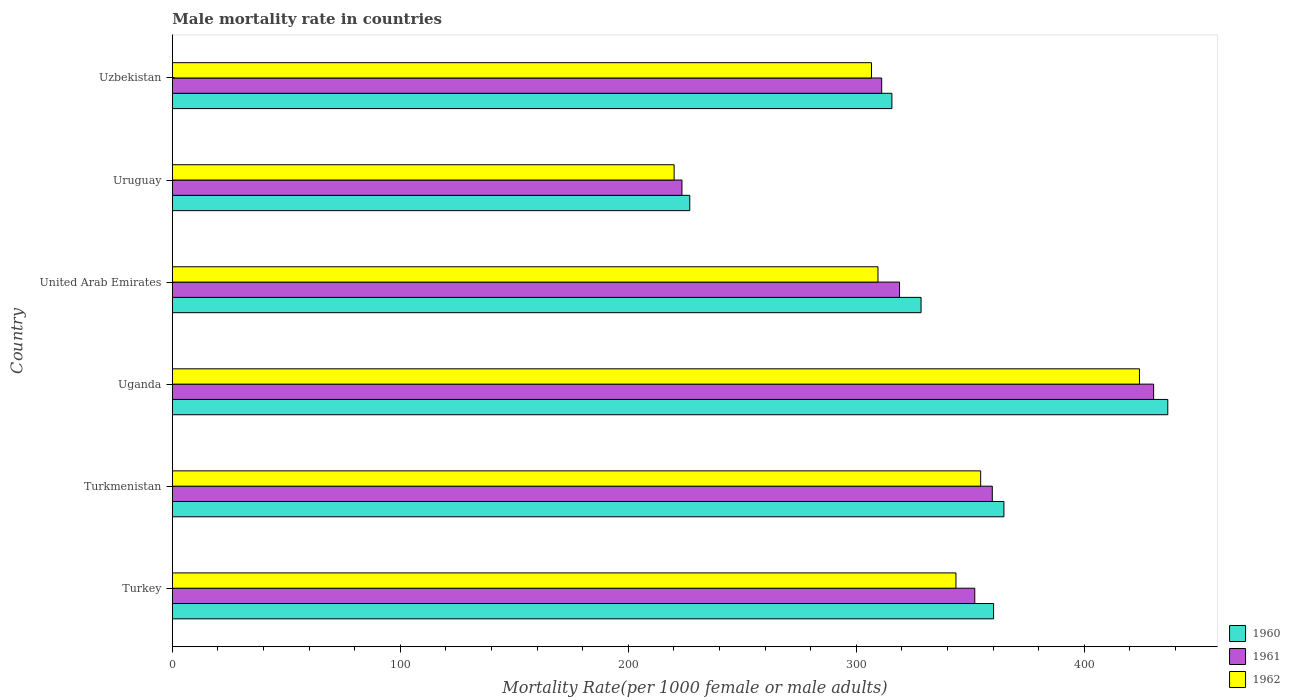How many groups of bars are there?
Your answer should be very brief. 6. How many bars are there on the 2nd tick from the bottom?
Your response must be concise. 3. What is the label of the 1st group of bars from the top?
Offer a very short reply. Uzbekistan. What is the male mortality rate in 1962 in Uganda?
Your answer should be compact. 424.16. Across all countries, what is the maximum male mortality rate in 1961?
Keep it short and to the point. 430.37. Across all countries, what is the minimum male mortality rate in 1962?
Provide a succinct answer. 220.07. In which country was the male mortality rate in 1962 maximum?
Provide a short and direct response. Uganda. In which country was the male mortality rate in 1962 minimum?
Give a very brief answer. Uruguay. What is the total male mortality rate in 1961 in the graph?
Offer a very short reply. 1995.46. What is the difference between the male mortality rate in 1962 in Turkey and that in Uganda?
Your answer should be very brief. -80.48. What is the difference between the male mortality rate in 1960 in Turkmenistan and the male mortality rate in 1962 in United Arab Emirates?
Ensure brevity in your answer.  55.24. What is the average male mortality rate in 1961 per country?
Ensure brevity in your answer.  332.58. What is the difference between the male mortality rate in 1961 and male mortality rate in 1960 in Uganda?
Your response must be concise. -6.21. What is the ratio of the male mortality rate in 1962 in Uganda to that in Uruguay?
Provide a short and direct response. 1.93. Is the male mortality rate in 1962 in Turkey less than that in Uruguay?
Your response must be concise. No. Is the difference between the male mortality rate in 1961 in Uruguay and Uzbekistan greater than the difference between the male mortality rate in 1960 in Uruguay and Uzbekistan?
Provide a succinct answer. Yes. What is the difference between the highest and the second highest male mortality rate in 1961?
Make the answer very short. 70.76. What is the difference between the highest and the lowest male mortality rate in 1960?
Ensure brevity in your answer.  209.65. In how many countries, is the male mortality rate in 1960 greater than the average male mortality rate in 1960 taken over all countries?
Your answer should be very brief. 3. Is the sum of the male mortality rate in 1962 in Turkey and United Arab Emirates greater than the maximum male mortality rate in 1961 across all countries?
Give a very brief answer. Yes. What does the 1st bar from the top in Uzbekistan represents?
Ensure brevity in your answer.  1962. Is it the case that in every country, the sum of the male mortality rate in 1962 and male mortality rate in 1960 is greater than the male mortality rate in 1961?
Ensure brevity in your answer.  Yes. How many bars are there?
Give a very brief answer. 18. Are all the bars in the graph horizontal?
Your answer should be compact. Yes. How many countries are there in the graph?
Offer a terse response. 6. What is the difference between two consecutive major ticks on the X-axis?
Make the answer very short. 100. Are the values on the major ticks of X-axis written in scientific E-notation?
Provide a succinct answer. No. Does the graph contain any zero values?
Offer a very short reply. No. Does the graph contain grids?
Offer a terse response. No. How are the legend labels stacked?
Provide a short and direct response. Vertical. What is the title of the graph?
Make the answer very short. Male mortality rate in countries. Does "2009" appear as one of the legend labels in the graph?
Offer a very short reply. No. What is the label or title of the X-axis?
Make the answer very short. Mortality Rate(per 1000 female or male adults). What is the label or title of the Y-axis?
Keep it short and to the point. Country. What is the Mortality Rate(per 1000 female or male adults) in 1960 in Turkey?
Offer a terse response. 360.19. What is the Mortality Rate(per 1000 female or male adults) in 1961 in Turkey?
Offer a very short reply. 351.93. What is the Mortality Rate(per 1000 female or male adults) in 1962 in Turkey?
Your answer should be very brief. 343.68. What is the Mortality Rate(per 1000 female or male adults) in 1960 in Turkmenistan?
Provide a short and direct response. 364.72. What is the Mortality Rate(per 1000 female or male adults) in 1961 in Turkmenistan?
Provide a short and direct response. 359.62. What is the Mortality Rate(per 1000 female or male adults) of 1962 in Turkmenistan?
Provide a short and direct response. 354.52. What is the Mortality Rate(per 1000 female or male adults) of 1960 in Uganda?
Keep it short and to the point. 436.58. What is the Mortality Rate(per 1000 female or male adults) in 1961 in Uganda?
Offer a terse response. 430.37. What is the Mortality Rate(per 1000 female or male adults) of 1962 in Uganda?
Provide a succinct answer. 424.16. What is the Mortality Rate(per 1000 female or male adults) of 1960 in United Arab Emirates?
Offer a terse response. 328.38. What is the Mortality Rate(per 1000 female or male adults) of 1961 in United Arab Emirates?
Give a very brief answer. 318.93. What is the Mortality Rate(per 1000 female or male adults) of 1962 in United Arab Emirates?
Your answer should be compact. 309.48. What is the Mortality Rate(per 1000 female or male adults) of 1960 in Uruguay?
Provide a succinct answer. 226.93. What is the Mortality Rate(per 1000 female or male adults) of 1961 in Uruguay?
Offer a terse response. 223.5. What is the Mortality Rate(per 1000 female or male adults) in 1962 in Uruguay?
Provide a short and direct response. 220.07. What is the Mortality Rate(per 1000 female or male adults) in 1960 in Uzbekistan?
Offer a very short reply. 315.58. What is the Mortality Rate(per 1000 female or male adults) of 1961 in Uzbekistan?
Your answer should be compact. 311.11. What is the Mortality Rate(per 1000 female or male adults) in 1962 in Uzbekistan?
Provide a succinct answer. 306.63. Across all countries, what is the maximum Mortality Rate(per 1000 female or male adults) in 1960?
Offer a terse response. 436.58. Across all countries, what is the maximum Mortality Rate(per 1000 female or male adults) of 1961?
Keep it short and to the point. 430.37. Across all countries, what is the maximum Mortality Rate(per 1000 female or male adults) in 1962?
Your answer should be compact. 424.16. Across all countries, what is the minimum Mortality Rate(per 1000 female or male adults) of 1960?
Provide a succinct answer. 226.93. Across all countries, what is the minimum Mortality Rate(per 1000 female or male adults) of 1961?
Offer a terse response. 223.5. Across all countries, what is the minimum Mortality Rate(per 1000 female or male adults) of 1962?
Your answer should be compact. 220.07. What is the total Mortality Rate(per 1000 female or male adults) of 1960 in the graph?
Ensure brevity in your answer.  2032.38. What is the total Mortality Rate(per 1000 female or male adults) of 1961 in the graph?
Provide a succinct answer. 1995.46. What is the total Mortality Rate(per 1000 female or male adults) of 1962 in the graph?
Provide a succinct answer. 1958.54. What is the difference between the Mortality Rate(per 1000 female or male adults) in 1960 in Turkey and that in Turkmenistan?
Your response must be concise. -4.53. What is the difference between the Mortality Rate(per 1000 female or male adults) of 1961 in Turkey and that in Turkmenistan?
Keep it short and to the point. -7.69. What is the difference between the Mortality Rate(per 1000 female or male adults) in 1962 in Turkey and that in Turkmenistan?
Your answer should be compact. -10.84. What is the difference between the Mortality Rate(per 1000 female or male adults) of 1960 in Turkey and that in Uganda?
Give a very brief answer. -76.4. What is the difference between the Mortality Rate(per 1000 female or male adults) of 1961 in Turkey and that in Uganda?
Offer a terse response. -78.44. What is the difference between the Mortality Rate(per 1000 female or male adults) in 1962 in Turkey and that in Uganda?
Ensure brevity in your answer.  -80.48. What is the difference between the Mortality Rate(per 1000 female or male adults) in 1960 in Turkey and that in United Arab Emirates?
Make the answer very short. 31.81. What is the difference between the Mortality Rate(per 1000 female or male adults) in 1961 in Turkey and that in United Arab Emirates?
Offer a very short reply. 33. What is the difference between the Mortality Rate(per 1000 female or male adults) of 1962 in Turkey and that in United Arab Emirates?
Your response must be concise. 34.2. What is the difference between the Mortality Rate(per 1000 female or male adults) in 1960 in Turkey and that in Uruguay?
Your answer should be compact. 133.25. What is the difference between the Mortality Rate(per 1000 female or male adults) in 1961 in Turkey and that in Uruguay?
Your answer should be very brief. 128.43. What is the difference between the Mortality Rate(per 1000 female or male adults) of 1962 in Turkey and that in Uruguay?
Provide a short and direct response. 123.61. What is the difference between the Mortality Rate(per 1000 female or male adults) of 1960 in Turkey and that in Uzbekistan?
Your response must be concise. 44.6. What is the difference between the Mortality Rate(per 1000 female or male adults) in 1961 in Turkey and that in Uzbekistan?
Give a very brief answer. 40.83. What is the difference between the Mortality Rate(per 1000 female or male adults) of 1962 in Turkey and that in Uzbekistan?
Ensure brevity in your answer.  37.05. What is the difference between the Mortality Rate(per 1000 female or male adults) of 1960 in Turkmenistan and that in Uganda?
Provide a short and direct response. -71.87. What is the difference between the Mortality Rate(per 1000 female or male adults) in 1961 in Turkmenistan and that in Uganda?
Provide a succinct answer. -70.76. What is the difference between the Mortality Rate(per 1000 female or male adults) in 1962 in Turkmenistan and that in Uganda?
Ensure brevity in your answer.  -69.64. What is the difference between the Mortality Rate(per 1000 female or male adults) of 1960 in Turkmenistan and that in United Arab Emirates?
Offer a terse response. 36.34. What is the difference between the Mortality Rate(per 1000 female or male adults) of 1961 in Turkmenistan and that in United Arab Emirates?
Provide a succinct answer. 40.69. What is the difference between the Mortality Rate(per 1000 female or male adults) of 1962 in Turkmenistan and that in United Arab Emirates?
Offer a very short reply. 45.04. What is the difference between the Mortality Rate(per 1000 female or male adults) in 1960 in Turkmenistan and that in Uruguay?
Keep it short and to the point. 137.78. What is the difference between the Mortality Rate(per 1000 female or male adults) of 1961 in Turkmenistan and that in Uruguay?
Provide a succinct answer. 136.12. What is the difference between the Mortality Rate(per 1000 female or male adults) of 1962 in Turkmenistan and that in Uruguay?
Provide a short and direct response. 134.45. What is the difference between the Mortality Rate(per 1000 female or male adults) of 1960 in Turkmenistan and that in Uzbekistan?
Make the answer very short. 49.14. What is the difference between the Mortality Rate(per 1000 female or male adults) of 1961 in Turkmenistan and that in Uzbekistan?
Offer a terse response. 48.51. What is the difference between the Mortality Rate(per 1000 female or male adults) of 1962 in Turkmenistan and that in Uzbekistan?
Your answer should be very brief. 47.89. What is the difference between the Mortality Rate(per 1000 female or male adults) of 1960 in Uganda and that in United Arab Emirates?
Your response must be concise. 108.21. What is the difference between the Mortality Rate(per 1000 female or male adults) in 1961 in Uganda and that in United Arab Emirates?
Ensure brevity in your answer.  111.44. What is the difference between the Mortality Rate(per 1000 female or male adults) in 1962 in Uganda and that in United Arab Emirates?
Your answer should be very brief. 114.68. What is the difference between the Mortality Rate(per 1000 female or male adults) in 1960 in Uganda and that in Uruguay?
Ensure brevity in your answer.  209.65. What is the difference between the Mortality Rate(per 1000 female or male adults) of 1961 in Uganda and that in Uruguay?
Keep it short and to the point. 206.87. What is the difference between the Mortality Rate(per 1000 female or male adults) of 1962 in Uganda and that in Uruguay?
Offer a terse response. 204.09. What is the difference between the Mortality Rate(per 1000 female or male adults) of 1960 in Uganda and that in Uzbekistan?
Offer a very short reply. 121. What is the difference between the Mortality Rate(per 1000 female or male adults) in 1961 in Uganda and that in Uzbekistan?
Your response must be concise. 119.27. What is the difference between the Mortality Rate(per 1000 female or male adults) of 1962 in Uganda and that in Uzbekistan?
Provide a succinct answer. 117.53. What is the difference between the Mortality Rate(per 1000 female or male adults) of 1960 in United Arab Emirates and that in Uruguay?
Give a very brief answer. 101.44. What is the difference between the Mortality Rate(per 1000 female or male adults) in 1961 in United Arab Emirates and that in Uruguay?
Offer a terse response. 95.43. What is the difference between the Mortality Rate(per 1000 female or male adults) of 1962 in United Arab Emirates and that in Uruguay?
Your answer should be compact. 89.41. What is the difference between the Mortality Rate(per 1000 female or male adults) of 1960 in United Arab Emirates and that in Uzbekistan?
Your answer should be very brief. 12.8. What is the difference between the Mortality Rate(per 1000 female or male adults) in 1961 in United Arab Emirates and that in Uzbekistan?
Ensure brevity in your answer.  7.82. What is the difference between the Mortality Rate(per 1000 female or male adults) in 1962 in United Arab Emirates and that in Uzbekistan?
Your response must be concise. 2.85. What is the difference between the Mortality Rate(per 1000 female or male adults) of 1960 in Uruguay and that in Uzbekistan?
Offer a very short reply. -88.65. What is the difference between the Mortality Rate(per 1000 female or male adults) of 1961 in Uruguay and that in Uzbekistan?
Provide a short and direct response. -87.6. What is the difference between the Mortality Rate(per 1000 female or male adults) of 1962 in Uruguay and that in Uzbekistan?
Keep it short and to the point. -86.56. What is the difference between the Mortality Rate(per 1000 female or male adults) of 1960 in Turkey and the Mortality Rate(per 1000 female or male adults) of 1961 in Turkmenistan?
Provide a succinct answer. 0.57. What is the difference between the Mortality Rate(per 1000 female or male adults) of 1960 in Turkey and the Mortality Rate(per 1000 female or male adults) of 1962 in Turkmenistan?
Your answer should be compact. 5.67. What is the difference between the Mortality Rate(per 1000 female or male adults) in 1961 in Turkey and the Mortality Rate(per 1000 female or male adults) in 1962 in Turkmenistan?
Ensure brevity in your answer.  -2.59. What is the difference between the Mortality Rate(per 1000 female or male adults) in 1960 in Turkey and the Mortality Rate(per 1000 female or male adults) in 1961 in Uganda?
Provide a succinct answer. -70.19. What is the difference between the Mortality Rate(per 1000 female or male adults) of 1960 in Turkey and the Mortality Rate(per 1000 female or male adults) of 1962 in Uganda?
Keep it short and to the point. -63.98. What is the difference between the Mortality Rate(per 1000 female or male adults) of 1961 in Turkey and the Mortality Rate(per 1000 female or male adults) of 1962 in Uganda?
Your answer should be compact. -72.23. What is the difference between the Mortality Rate(per 1000 female or male adults) of 1960 in Turkey and the Mortality Rate(per 1000 female or male adults) of 1961 in United Arab Emirates?
Give a very brief answer. 41.26. What is the difference between the Mortality Rate(per 1000 female or male adults) of 1960 in Turkey and the Mortality Rate(per 1000 female or male adults) of 1962 in United Arab Emirates?
Keep it short and to the point. 50.7. What is the difference between the Mortality Rate(per 1000 female or male adults) of 1961 in Turkey and the Mortality Rate(per 1000 female or male adults) of 1962 in United Arab Emirates?
Offer a very short reply. 42.45. What is the difference between the Mortality Rate(per 1000 female or male adults) in 1960 in Turkey and the Mortality Rate(per 1000 female or male adults) in 1961 in Uruguay?
Give a very brief answer. 136.68. What is the difference between the Mortality Rate(per 1000 female or male adults) of 1960 in Turkey and the Mortality Rate(per 1000 female or male adults) of 1962 in Uruguay?
Provide a short and direct response. 140.11. What is the difference between the Mortality Rate(per 1000 female or male adults) of 1961 in Turkey and the Mortality Rate(per 1000 female or male adults) of 1962 in Uruguay?
Make the answer very short. 131.86. What is the difference between the Mortality Rate(per 1000 female or male adults) of 1960 in Turkey and the Mortality Rate(per 1000 female or male adults) of 1961 in Uzbekistan?
Your response must be concise. 49.08. What is the difference between the Mortality Rate(per 1000 female or male adults) of 1960 in Turkey and the Mortality Rate(per 1000 female or male adults) of 1962 in Uzbekistan?
Give a very brief answer. 53.55. What is the difference between the Mortality Rate(per 1000 female or male adults) in 1961 in Turkey and the Mortality Rate(per 1000 female or male adults) in 1962 in Uzbekistan?
Provide a succinct answer. 45.3. What is the difference between the Mortality Rate(per 1000 female or male adults) of 1960 in Turkmenistan and the Mortality Rate(per 1000 female or male adults) of 1961 in Uganda?
Your answer should be compact. -65.66. What is the difference between the Mortality Rate(per 1000 female or male adults) of 1960 in Turkmenistan and the Mortality Rate(per 1000 female or male adults) of 1962 in Uganda?
Make the answer very short. -59.45. What is the difference between the Mortality Rate(per 1000 female or male adults) in 1961 in Turkmenistan and the Mortality Rate(per 1000 female or male adults) in 1962 in Uganda?
Ensure brevity in your answer.  -64.55. What is the difference between the Mortality Rate(per 1000 female or male adults) of 1960 in Turkmenistan and the Mortality Rate(per 1000 female or male adults) of 1961 in United Arab Emirates?
Keep it short and to the point. 45.79. What is the difference between the Mortality Rate(per 1000 female or male adults) of 1960 in Turkmenistan and the Mortality Rate(per 1000 female or male adults) of 1962 in United Arab Emirates?
Provide a succinct answer. 55.24. What is the difference between the Mortality Rate(per 1000 female or male adults) of 1961 in Turkmenistan and the Mortality Rate(per 1000 female or male adults) of 1962 in United Arab Emirates?
Your answer should be compact. 50.14. What is the difference between the Mortality Rate(per 1000 female or male adults) in 1960 in Turkmenistan and the Mortality Rate(per 1000 female or male adults) in 1961 in Uruguay?
Your response must be concise. 141.22. What is the difference between the Mortality Rate(per 1000 female or male adults) of 1960 in Turkmenistan and the Mortality Rate(per 1000 female or male adults) of 1962 in Uruguay?
Your answer should be compact. 144.65. What is the difference between the Mortality Rate(per 1000 female or male adults) of 1961 in Turkmenistan and the Mortality Rate(per 1000 female or male adults) of 1962 in Uruguay?
Make the answer very short. 139.55. What is the difference between the Mortality Rate(per 1000 female or male adults) in 1960 in Turkmenistan and the Mortality Rate(per 1000 female or male adults) in 1961 in Uzbekistan?
Your answer should be compact. 53.61. What is the difference between the Mortality Rate(per 1000 female or male adults) of 1960 in Turkmenistan and the Mortality Rate(per 1000 female or male adults) of 1962 in Uzbekistan?
Make the answer very short. 58.09. What is the difference between the Mortality Rate(per 1000 female or male adults) in 1961 in Turkmenistan and the Mortality Rate(per 1000 female or male adults) in 1962 in Uzbekistan?
Provide a short and direct response. 52.99. What is the difference between the Mortality Rate(per 1000 female or male adults) in 1960 in Uganda and the Mortality Rate(per 1000 female or male adults) in 1961 in United Arab Emirates?
Your response must be concise. 117.65. What is the difference between the Mortality Rate(per 1000 female or male adults) in 1960 in Uganda and the Mortality Rate(per 1000 female or male adults) in 1962 in United Arab Emirates?
Offer a terse response. 127.1. What is the difference between the Mortality Rate(per 1000 female or male adults) of 1961 in Uganda and the Mortality Rate(per 1000 female or male adults) of 1962 in United Arab Emirates?
Offer a terse response. 120.89. What is the difference between the Mortality Rate(per 1000 female or male adults) of 1960 in Uganda and the Mortality Rate(per 1000 female or male adults) of 1961 in Uruguay?
Your response must be concise. 213.08. What is the difference between the Mortality Rate(per 1000 female or male adults) in 1960 in Uganda and the Mortality Rate(per 1000 female or male adults) in 1962 in Uruguay?
Keep it short and to the point. 216.51. What is the difference between the Mortality Rate(per 1000 female or male adults) in 1961 in Uganda and the Mortality Rate(per 1000 female or male adults) in 1962 in Uruguay?
Provide a short and direct response. 210.3. What is the difference between the Mortality Rate(per 1000 female or male adults) in 1960 in Uganda and the Mortality Rate(per 1000 female or male adults) in 1961 in Uzbekistan?
Provide a short and direct response. 125.48. What is the difference between the Mortality Rate(per 1000 female or male adults) in 1960 in Uganda and the Mortality Rate(per 1000 female or male adults) in 1962 in Uzbekistan?
Give a very brief answer. 129.95. What is the difference between the Mortality Rate(per 1000 female or male adults) in 1961 in Uganda and the Mortality Rate(per 1000 female or male adults) in 1962 in Uzbekistan?
Offer a very short reply. 123.74. What is the difference between the Mortality Rate(per 1000 female or male adults) of 1960 in United Arab Emirates and the Mortality Rate(per 1000 female or male adults) of 1961 in Uruguay?
Your response must be concise. 104.88. What is the difference between the Mortality Rate(per 1000 female or male adults) in 1960 in United Arab Emirates and the Mortality Rate(per 1000 female or male adults) in 1962 in Uruguay?
Your response must be concise. 108.31. What is the difference between the Mortality Rate(per 1000 female or male adults) in 1961 in United Arab Emirates and the Mortality Rate(per 1000 female or male adults) in 1962 in Uruguay?
Ensure brevity in your answer.  98.86. What is the difference between the Mortality Rate(per 1000 female or male adults) in 1960 in United Arab Emirates and the Mortality Rate(per 1000 female or male adults) in 1961 in Uzbekistan?
Provide a succinct answer. 17.27. What is the difference between the Mortality Rate(per 1000 female or male adults) of 1960 in United Arab Emirates and the Mortality Rate(per 1000 female or male adults) of 1962 in Uzbekistan?
Offer a terse response. 21.75. What is the difference between the Mortality Rate(per 1000 female or male adults) of 1961 in United Arab Emirates and the Mortality Rate(per 1000 female or male adults) of 1962 in Uzbekistan?
Ensure brevity in your answer.  12.3. What is the difference between the Mortality Rate(per 1000 female or male adults) in 1960 in Uruguay and the Mortality Rate(per 1000 female or male adults) in 1961 in Uzbekistan?
Your answer should be very brief. -84.17. What is the difference between the Mortality Rate(per 1000 female or male adults) in 1960 in Uruguay and the Mortality Rate(per 1000 female or male adults) in 1962 in Uzbekistan?
Your response must be concise. -79.7. What is the difference between the Mortality Rate(per 1000 female or male adults) of 1961 in Uruguay and the Mortality Rate(per 1000 female or male adults) of 1962 in Uzbekistan?
Make the answer very short. -83.13. What is the average Mortality Rate(per 1000 female or male adults) in 1960 per country?
Ensure brevity in your answer.  338.73. What is the average Mortality Rate(per 1000 female or male adults) of 1961 per country?
Ensure brevity in your answer.  332.58. What is the average Mortality Rate(per 1000 female or male adults) of 1962 per country?
Give a very brief answer. 326.42. What is the difference between the Mortality Rate(per 1000 female or male adults) in 1960 and Mortality Rate(per 1000 female or male adults) in 1961 in Turkey?
Keep it short and to the point. 8.25. What is the difference between the Mortality Rate(per 1000 female or male adults) of 1960 and Mortality Rate(per 1000 female or male adults) of 1962 in Turkey?
Offer a terse response. 16.51. What is the difference between the Mortality Rate(per 1000 female or male adults) of 1961 and Mortality Rate(per 1000 female or male adults) of 1962 in Turkey?
Provide a short and direct response. 8.25. What is the difference between the Mortality Rate(per 1000 female or male adults) of 1960 and Mortality Rate(per 1000 female or male adults) of 1961 in Uganda?
Offer a terse response. 6.21. What is the difference between the Mortality Rate(per 1000 female or male adults) of 1960 and Mortality Rate(per 1000 female or male adults) of 1962 in Uganda?
Ensure brevity in your answer.  12.42. What is the difference between the Mortality Rate(per 1000 female or male adults) in 1961 and Mortality Rate(per 1000 female or male adults) in 1962 in Uganda?
Ensure brevity in your answer.  6.21. What is the difference between the Mortality Rate(per 1000 female or male adults) of 1960 and Mortality Rate(per 1000 female or male adults) of 1961 in United Arab Emirates?
Your answer should be very brief. 9.45. What is the difference between the Mortality Rate(per 1000 female or male adults) in 1960 and Mortality Rate(per 1000 female or male adults) in 1962 in United Arab Emirates?
Your answer should be very brief. 18.9. What is the difference between the Mortality Rate(per 1000 female or male adults) of 1961 and Mortality Rate(per 1000 female or male adults) of 1962 in United Arab Emirates?
Your answer should be very brief. 9.45. What is the difference between the Mortality Rate(per 1000 female or male adults) in 1960 and Mortality Rate(per 1000 female or male adults) in 1961 in Uruguay?
Your response must be concise. 3.43. What is the difference between the Mortality Rate(per 1000 female or male adults) of 1960 and Mortality Rate(per 1000 female or male adults) of 1962 in Uruguay?
Ensure brevity in your answer.  6.86. What is the difference between the Mortality Rate(per 1000 female or male adults) of 1961 and Mortality Rate(per 1000 female or male adults) of 1962 in Uruguay?
Offer a terse response. 3.43. What is the difference between the Mortality Rate(per 1000 female or male adults) of 1960 and Mortality Rate(per 1000 female or male adults) of 1961 in Uzbekistan?
Give a very brief answer. 4.48. What is the difference between the Mortality Rate(per 1000 female or male adults) in 1960 and Mortality Rate(per 1000 female or male adults) in 1962 in Uzbekistan?
Provide a succinct answer. 8.95. What is the difference between the Mortality Rate(per 1000 female or male adults) in 1961 and Mortality Rate(per 1000 female or male adults) in 1962 in Uzbekistan?
Provide a succinct answer. 4.48. What is the ratio of the Mortality Rate(per 1000 female or male adults) of 1960 in Turkey to that in Turkmenistan?
Your answer should be compact. 0.99. What is the ratio of the Mortality Rate(per 1000 female or male adults) in 1961 in Turkey to that in Turkmenistan?
Give a very brief answer. 0.98. What is the ratio of the Mortality Rate(per 1000 female or male adults) in 1962 in Turkey to that in Turkmenistan?
Provide a succinct answer. 0.97. What is the ratio of the Mortality Rate(per 1000 female or male adults) of 1960 in Turkey to that in Uganda?
Make the answer very short. 0.82. What is the ratio of the Mortality Rate(per 1000 female or male adults) of 1961 in Turkey to that in Uganda?
Make the answer very short. 0.82. What is the ratio of the Mortality Rate(per 1000 female or male adults) in 1962 in Turkey to that in Uganda?
Your answer should be very brief. 0.81. What is the ratio of the Mortality Rate(per 1000 female or male adults) in 1960 in Turkey to that in United Arab Emirates?
Make the answer very short. 1.1. What is the ratio of the Mortality Rate(per 1000 female or male adults) in 1961 in Turkey to that in United Arab Emirates?
Your answer should be compact. 1.1. What is the ratio of the Mortality Rate(per 1000 female or male adults) in 1962 in Turkey to that in United Arab Emirates?
Your answer should be very brief. 1.11. What is the ratio of the Mortality Rate(per 1000 female or male adults) of 1960 in Turkey to that in Uruguay?
Provide a short and direct response. 1.59. What is the ratio of the Mortality Rate(per 1000 female or male adults) in 1961 in Turkey to that in Uruguay?
Ensure brevity in your answer.  1.57. What is the ratio of the Mortality Rate(per 1000 female or male adults) of 1962 in Turkey to that in Uruguay?
Offer a very short reply. 1.56. What is the ratio of the Mortality Rate(per 1000 female or male adults) in 1960 in Turkey to that in Uzbekistan?
Provide a short and direct response. 1.14. What is the ratio of the Mortality Rate(per 1000 female or male adults) in 1961 in Turkey to that in Uzbekistan?
Ensure brevity in your answer.  1.13. What is the ratio of the Mortality Rate(per 1000 female or male adults) in 1962 in Turkey to that in Uzbekistan?
Ensure brevity in your answer.  1.12. What is the ratio of the Mortality Rate(per 1000 female or male adults) in 1960 in Turkmenistan to that in Uganda?
Your answer should be compact. 0.84. What is the ratio of the Mortality Rate(per 1000 female or male adults) in 1961 in Turkmenistan to that in Uganda?
Keep it short and to the point. 0.84. What is the ratio of the Mortality Rate(per 1000 female or male adults) in 1962 in Turkmenistan to that in Uganda?
Keep it short and to the point. 0.84. What is the ratio of the Mortality Rate(per 1000 female or male adults) of 1960 in Turkmenistan to that in United Arab Emirates?
Give a very brief answer. 1.11. What is the ratio of the Mortality Rate(per 1000 female or male adults) of 1961 in Turkmenistan to that in United Arab Emirates?
Give a very brief answer. 1.13. What is the ratio of the Mortality Rate(per 1000 female or male adults) of 1962 in Turkmenistan to that in United Arab Emirates?
Your answer should be compact. 1.15. What is the ratio of the Mortality Rate(per 1000 female or male adults) of 1960 in Turkmenistan to that in Uruguay?
Make the answer very short. 1.61. What is the ratio of the Mortality Rate(per 1000 female or male adults) of 1961 in Turkmenistan to that in Uruguay?
Provide a succinct answer. 1.61. What is the ratio of the Mortality Rate(per 1000 female or male adults) of 1962 in Turkmenistan to that in Uruguay?
Make the answer very short. 1.61. What is the ratio of the Mortality Rate(per 1000 female or male adults) in 1960 in Turkmenistan to that in Uzbekistan?
Offer a very short reply. 1.16. What is the ratio of the Mortality Rate(per 1000 female or male adults) of 1961 in Turkmenistan to that in Uzbekistan?
Offer a terse response. 1.16. What is the ratio of the Mortality Rate(per 1000 female or male adults) in 1962 in Turkmenistan to that in Uzbekistan?
Offer a very short reply. 1.16. What is the ratio of the Mortality Rate(per 1000 female or male adults) in 1960 in Uganda to that in United Arab Emirates?
Keep it short and to the point. 1.33. What is the ratio of the Mortality Rate(per 1000 female or male adults) in 1961 in Uganda to that in United Arab Emirates?
Offer a terse response. 1.35. What is the ratio of the Mortality Rate(per 1000 female or male adults) in 1962 in Uganda to that in United Arab Emirates?
Make the answer very short. 1.37. What is the ratio of the Mortality Rate(per 1000 female or male adults) of 1960 in Uganda to that in Uruguay?
Your answer should be very brief. 1.92. What is the ratio of the Mortality Rate(per 1000 female or male adults) in 1961 in Uganda to that in Uruguay?
Provide a succinct answer. 1.93. What is the ratio of the Mortality Rate(per 1000 female or male adults) in 1962 in Uganda to that in Uruguay?
Ensure brevity in your answer.  1.93. What is the ratio of the Mortality Rate(per 1000 female or male adults) in 1960 in Uganda to that in Uzbekistan?
Ensure brevity in your answer.  1.38. What is the ratio of the Mortality Rate(per 1000 female or male adults) in 1961 in Uganda to that in Uzbekistan?
Give a very brief answer. 1.38. What is the ratio of the Mortality Rate(per 1000 female or male adults) in 1962 in Uganda to that in Uzbekistan?
Offer a very short reply. 1.38. What is the ratio of the Mortality Rate(per 1000 female or male adults) of 1960 in United Arab Emirates to that in Uruguay?
Keep it short and to the point. 1.45. What is the ratio of the Mortality Rate(per 1000 female or male adults) of 1961 in United Arab Emirates to that in Uruguay?
Offer a very short reply. 1.43. What is the ratio of the Mortality Rate(per 1000 female or male adults) of 1962 in United Arab Emirates to that in Uruguay?
Provide a succinct answer. 1.41. What is the ratio of the Mortality Rate(per 1000 female or male adults) of 1960 in United Arab Emirates to that in Uzbekistan?
Make the answer very short. 1.04. What is the ratio of the Mortality Rate(per 1000 female or male adults) in 1961 in United Arab Emirates to that in Uzbekistan?
Give a very brief answer. 1.03. What is the ratio of the Mortality Rate(per 1000 female or male adults) in 1962 in United Arab Emirates to that in Uzbekistan?
Your response must be concise. 1.01. What is the ratio of the Mortality Rate(per 1000 female or male adults) of 1960 in Uruguay to that in Uzbekistan?
Your answer should be very brief. 0.72. What is the ratio of the Mortality Rate(per 1000 female or male adults) in 1961 in Uruguay to that in Uzbekistan?
Keep it short and to the point. 0.72. What is the ratio of the Mortality Rate(per 1000 female or male adults) of 1962 in Uruguay to that in Uzbekistan?
Your answer should be very brief. 0.72. What is the difference between the highest and the second highest Mortality Rate(per 1000 female or male adults) in 1960?
Your answer should be very brief. 71.87. What is the difference between the highest and the second highest Mortality Rate(per 1000 female or male adults) of 1961?
Provide a short and direct response. 70.76. What is the difference between the highest and the second highest Mortality Rate(per 1000 female or male adults) of 1962?
Provide a succinct answer. 69.64. What is the difference between the highest and the lowest Mortality Rate(per 1000 female or male adults) in 1960?
Give a very brief answer. 209.65. What is the difference between the highest and the lowest Mortality Rate(per 1000 female or male adults) of 1961?
Provide a short and direct response. 206.87. What is the difference between the highest and the lowest Mortality Rate(per 1000 female or male adults) in 1962?
Ensure brevity in your answer.  204.09. 